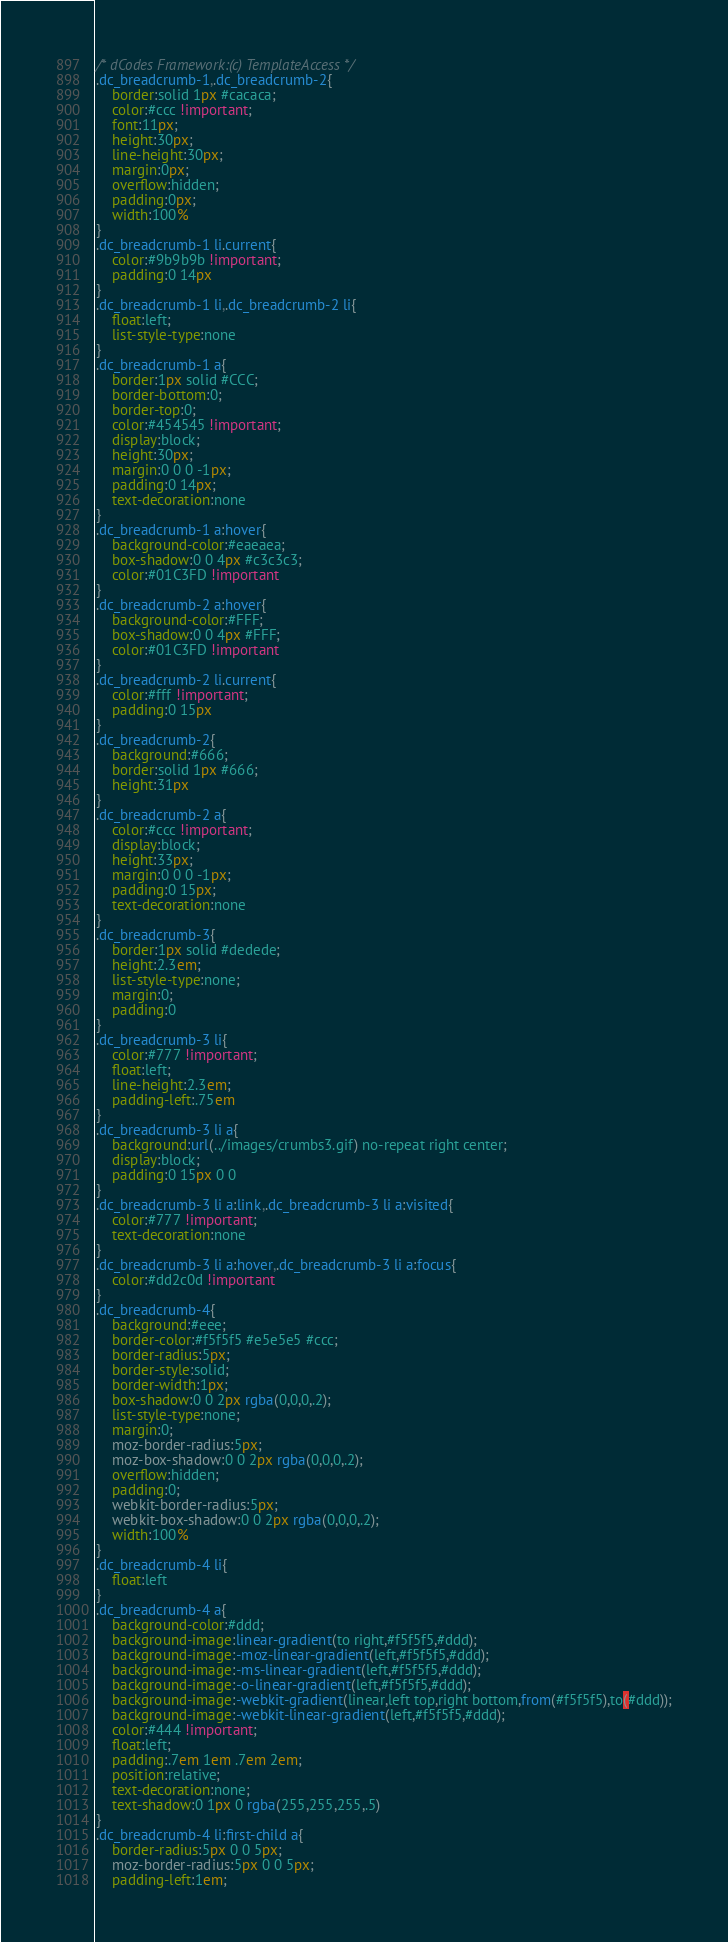<code> <loc_0><loc_0><loc_500><loc_500><_CSS_>/* dCodes Framework:(c) TemplateAccess */
.dc_breadcrumb-1,.dc_breadcrumb-2{
	border:solid 1px #cacaca;
	color:#ccc !important;
	font:11px;
	height:30px;
	line-height:30px;
	margin:0px;
	overflow:hidden;
	padding:0px;
	width:100%
}
.dc_breadcrumb-1 li.current{
	color:#9b9b9b !important;
	padding:0 14px
}
.dc_breadcrumb-1 li,.dc_breadcrumb-2 li{
	float:left;
	list-style-type:none
}
.dc_breadcrumb-1 a{
	border:1px solid #CCC;
	border-bottom:0;
	border-top:0;
	color:#454545 !important;
	display:block;
	height:30px;
	margin:0 0 0 -1px;
	padding:0 14px;
	text-decoration:none
}
.dc_breadcrumb-1 a:hover{
	background-color:#eaeaea;
	box-shadow:0 0 4px #c3c3c3;
	color:#01C3FD !important
}
.dc_breadcrumb-2 a:hover{
	background-color:#FFF;
	box-shadow:0 0 4px #FFF;
	color:#01C3FD !important
}
.dc_breadcrumb-2 li.current{
	color:#fff !important;
	padding:0 15px
}
.dc_breadcrumb-2{
	background:#666;
	border:solid 1px #666;
	height:31px
}
.dc_breadcrumb-2 a{
	color:#ccc !important;
	display:block;
	height:33px;
	margin:0 0 0 -1px;
	padding:0 15px;
	text-decoration:none
}
.dc_breadcrumb-3{
	border:1px solid #dedede;
	height:2.3em;
	list-style-type:none;
	margin:0;
	padding:0
}
.dc_breadcrumb-3 li{
	color:#777 !important;
	float:left;
	line-height:2.3em;
	padding-left:.75em
}
.dc_breadcrumb-3 li a{
	background:url(../images/crumbs3.gif) no-repeat right center;
	display:block;
	padding:0 15px 0 0
}
.dc_breadcrumb-3 li a:link,.dc_breadcrumb-3 li a:visited{
	color:#777 !important;
	text-decoration:none
}
.dc_breadcrumb-3 li a:hover,.dc_breadcrumb-3 li a:focus{
	color:#dd2c0d !important
}
.dc_breadcrumb-4{
	background:#eee;
	border-color:#f5f5f5 #e5e5e5 #ccc;
	border-radius:5px;
	border-style:solid;
	border-width:1px;
	box-shadow:0 0 2px rgba(0,0,0,.2);
	list-style-type:none;
	margin:0;
	moz-border-radius:5px;
	moz-box-shadow:0 0 2px rgba(0,0,0,.2);
	overflow:hidden;
	padding:0;
	webkit-border-radius:5px;
	webkit-box-shadow:0 0 2px rgba(0,0,0,.2);
	width:100%
}
.dc_breadcrumb-4 li{
	float:left
}
.dc_breadcrumb-4 a{
	background-color:#ddd;
	background-image:linear-gradient(to right,#f5f5f5,#ddd);
	background-image:-moz-linear-gradient(left,#f5f5f5,#ddd);
	background-image:-ms-linear-gradient(left,#f5f5f5,#ddd);
	background-image:-o-linear-gradient(left,#f5f5f5,#ddd);
	background-image:-webkit-gradient(linear,left top,right bottom,from(#f5f5f5),to(#ddd));
	background-image:-webkit-linear-gradient(left,#f5f5f5,#ddd);
	color:#444 !important;
	float:left;
	padding:.7em 1em .7em 2em;
	position:relative;
	text-decoration:none;
	text-shadow:0 1px 0 rgba(255,255,255,.5)
}
.dc_breadcrumb-4 li:first-child a{
	border-radius:5px 0 0 5px;
	moz-border-radius:5px 0 0 5px;
	padding-left:1em;</code> 